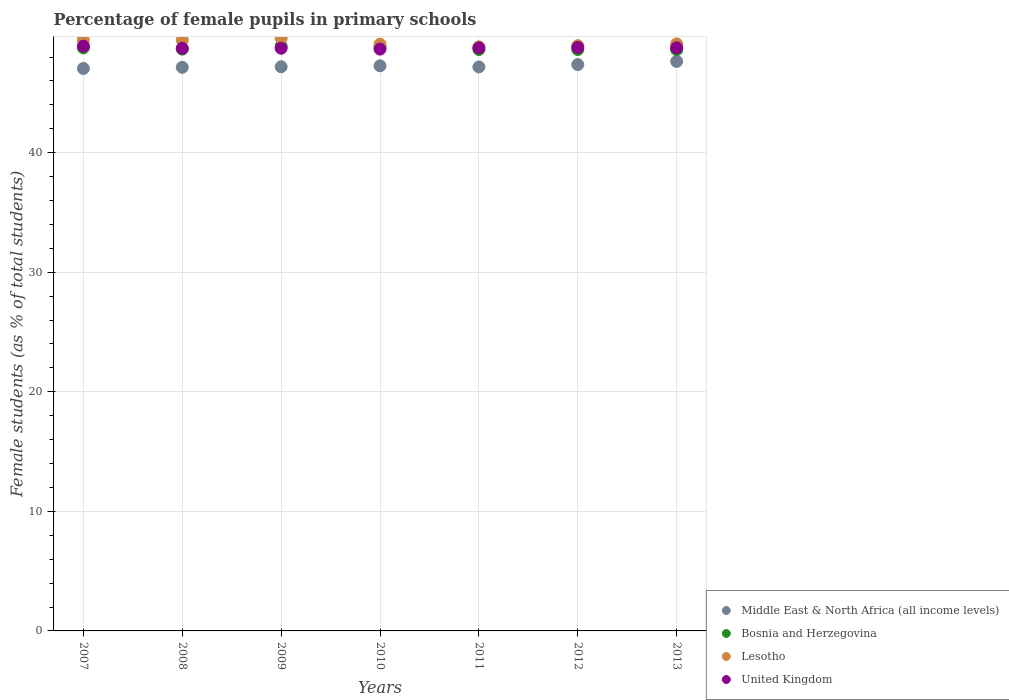What is the percentage of female pupils in primary schools in Lesotho in 2013?
Keep it short and to the point. 49.1. Across all years, what is the maximum percentage of female pupils in primary schools in Middle East & North Africa (all income levels)?
Give a very brief answer. 47.64. Across all years, what is the minimum percentage of female pupils in primary schools in United Kingdom?
Offer a terse response. 48.67. In which year was the percentage of female pupils in primary schools in Bosnia and Herzegovina maximum?
Provide a succinct answer. 2009. What is the total percentage of female pupils in primary schools in Lesotho in the graph?
Ensure brevity in your answer.  344.43. What is the difference between the percentage of female pupils in primary schools in Middle East & North Africa (all income levels) in 2011 and that in 2012?
Provide a short and direct response. -0.2. What is the difference between the percentage of female pupils in primary schools in United Kingdom in 2009 and the percentage of female pupils in primary schools in Bosnia and Herzegovina in 2007?
Keep it short and to the point. -0.04. What is the average percentage of female pupils in primary schools in Lesotho per year?
Your answer should be very brief. 49.2. In the year 2011, what is the difference between the percentage of female pupils in primary schools in United Kingdom and percentage of female pupils in primary schools in Middle East & North Africa (all income levels)?
Keep it short and to the point. 1.59. What is the ratio of the percentage of female pupils in primary schools in Bosnia and Herzegovina in 2010 to that in 2011?
Your answer should be very brief. 1. What is the difference between the highest and the second highest percentage of female pupils in primary schools in Middle East & North Africa (all income levels)?
Your response must be concise. 0.27. What is the difference between the highest and the lowest percentage of female pupils in primary schools in Lesotho?
Keep it short and to the point. 0.73. In how many years, is the percentage of female pupils in primary schools in Lesotho greater than the average percentage of female pupils in primary schools in Lesotho taken over all years?
Keep it short and to the point. 3. Is it the case that in every year, the sum of the percentage of female pupils in primary schools in Bosnia and Herzegovina and percentage of female pupils in primary schools in Middle East & North Africa (all income levels)  is greater than the sum of percentage of female pupils in primary schools in Lesotho and percentage of female pupils in primary schools in United Kingdom?
Provide a short and direct response. Yes. Is the percentage of female pupils in primary schools in Lesotho strictly less than the percentage of female pupils in primary schools in Bosnia and Herzegovina over the years?
Provide a short and direct response. No. Does the graph contain any zero values?
Offer a very short reply. No. What is the title of the graph?
Your answer should be compact. Percentage of female pupils in primary schools. What is the label or title of the Y-axis?
Offer a terse response. Female students (as % of total students). What is the Female students (as % of total students) of Middle East & North Africa (all income levels) in 2007?
Make the answer very short. 47.04. What is the Female students (as % of total students) of Bosnia and Herzegovina in 2007?
Keep it short and to the point. 48.77. What is the Female students (as % of total students) in Lesotho in 2007?
Your response must be concise. 49.44. What is the Female students (as % of total students) of United Kingdom in 2007?
Offer a terse response. 48.91. What is the Female students (as % of total students) of Middle East & North Africa (all income levels) in 2008?
Your response must be concise. 47.14. What is the Female students (as % of total students) in Bosnia and Herzegovina in 2008?
Your answer should be very brief. 48.67. What is the Female students (as % of total students) in Lesotho in 2008?
Your answer should be compact. 49.42. What is the Female students (as % of total students) of United Kingdom in 2008?
Make the answer very short. 48.73. What is the Female students (as % of total students) in Middle East & North Africa (all income levels) in 2009?
Make the answer very short. 47.19. What is the Female students (as % of total students) of Bosnia and Herzegovina in 2009?
Your answer should be compact. 48.91. What is the Female students (as % of total students) in Lesotho in 2009?
Offer a very short reply. 49.59. What is the Female students (as % of total students) of United Kingdom in 2009?
Offer a terse response. 48.74. What is the Female students (as % of total students) in Middle East & North Africa (all income levels) in 2010?
Offer a terse response. 47.27. What is the Female students (as % of total students) of Bosnia and Herzegovina in 2010?
Offer a very short reply. 48.86. What is the Female students (as % of total students) in Lesotho in 2010?
Your answer should be compact. 49.08. What is the Female students (as % of total students) in United Kingdom in 2010?
Give a very brief answer. 48.67. What is the Female students (as % of total students) of Middle East & North Africa (all income levels) in 2011?
Offer a very short reply. 47.17. What is the Female students (as % of total students) in Bosnia and Herzegovina in 2011?
Give a very brief answer. 48.63. What is the Female students (as % of total students) of Lesotho in 2011?
Your answer should be very brief. 48.86. What is the Female students (as % of total students) of United Kingdom in 2011?
Ensure brevity in your answer.  48.77. What is the Female students (as % of total students) in Middle East & North Africa (all income levels) in 2012?
Your response must be concise. 47.37. What is the Female students (as % of total students) of Bosnia and Herzegovina in 2012?
Give a very brief answer. 48.63. What is the Female students (as % of total students) in Lesotho in 2012?
Offer a terse response. 48.95. What is the Female students (as % of total students) of United Kingdom in 2012?
Provide a short and direct response. 48.81. What is the Female students (as % of total students) in Middle East & North Africa (all income levels) in 2013?
Offer a very short reply. 47.64. What is the Female students (as % of total students) in Bosnia and Herzegovina in 2013?
Keep it short and to the point. 48.61. What is the Female students (as % of total students) of Lesotho in 2013?
Offer a terse response. 49.1. What is the Female students (as % of total students) of United Kingdom in 2013?
Offer a very short reply. 48.77. Across all years, what is the maximum Female students (as % of total students) in Middle East & North Africa (all income levels)?
Ensure brevity in your answer.  47.64. Across all years, what is the maximum Female students (as % of total students) in Bosnia and Herzegovina?
Keep it short and to the point. 48.91. Across all years, what is the maximum Female students (as % of total students) of Lesotho?
Provide a succinct answer. 49.59. Across all years, what is the maximum Female students (as % of total students) of United Kingdom?
Your response must be concise. 48.91. Across all years, what is the minimum Female students (as % of total students) in Middle East & North Africa (all income levels)?
Offer a terse response. 47.04. Across all years, what is the minimum Female students (as % of total students) of Bosnia and Herzegovina?
Keep it short and to the point. 48.61. Across all years, what is the minimum Female students (as % of total students) in Lesotho?
Offer a terse response. 48.86. Across all years, what is the minimum Female students (as % of total students) of United Kingdom?
Offer a terse response. 48.67. What is the total Female students (as % of total students) in Middle East & North Africa (all income levels) in the graph?
Offer a very short reply. 330.83. What is the total Female students (as % of total students) in Bosnia and Herzegovina in the graph?
Your answer should be very brief. 341.09. What is the total Female students (as % of total students) of Lesotho in the graph?
Make the answer very short. 344.43. What is the total Female students (as % of total students) of United Kingdom in the graph?
Offer a terse response. 341.4. What is the difference between the Female students (as % of total students) in Middle East & North Africa (all income levels) in 2007 and that in 2008?
Keep it short and to the point. -0.1. What is the difference between the Female students (as % of total students) of Bosnia and Herzegovina in 2007 and that in 2008?
Provide a short and direct response. 0.1. What is the difference between the Female students (as % of total students) in Lesotho in 2007 and that in 2008?
Keep it short and to the point. 0.02. What is the difference between the Female students (as % of total students) in United Kingdom in 2007 and that in 2008?
Your answer should be compact. 0.18. What is the difference between the Female students (as % of total students) in Middle East & North Africa (all income levels) in 2007 and that in 2009?
Your answer should be very brief. -0.15. What is the difference between the Female students (as % of total students) of Bosnia and Herzegovina in 2007 and that in 2009?
Make the answer very short. -0.14. What is the difference between the Female students (as % of total students) of Lesotho in 2007 and that in 2009?
Offer a very short reply. -0.15. What is the difference between the Female students (as % of total students) in United Kingdom in 2007 and that in 2009?
Your response must be concise. 0.18. What is the difference between the Female students (as % of total students) of Middle East & North Africa (all income levels) in 2007 and that in 2010?
Provide a short and direct response. -0.23. What is the difference between the Female students (as % of total students) in Bosnia and Herzegovina in 2007 and that in 2010?
Ensure brevity in your answer.  -0.09. What is the difference between the Female students (as % of total students) in Lesotho in 2007 and that in 2010?
Provide a succinct answer. 0.36. What is the difference between the Female students (as % of total students) of United Kingdom in 2007 and that in 2010?
Your answer should be very brief. 0.25. What is the difference between the Female students (as % of total students) of Middle East & North Africa (all income levels) in 2007 and that in 2011?
Make the answer very short. -0.13. What is the difference between the Female students (as % of total students) of Bosnia and Herzegovina in 2007 and that in 2011?
Your answer should be compact. 0.14. What is the difference between the Female students (as % of total students) of Lesotho in 2007 and that in 2011?
Offer a terse response. 0.58. What is the difference between the Female students (as % of total students) of United Kingdom in 2007 and that in 2011?
Offer a terse response. 0.14. What is the difference between the Female students (as % of total students) of Middle East & North Africa (all income levels) in 2007 and that in 2012?
Your answer should be compact. -0.33. What is the difference between the Female students (as % of total students) in Bosnia and Herzegovina in 2007 and that in 2012?
Ensure brevity in your answer.  0.14. What is the difference between the Female students (as % of total students) of Lesotho in 2007 and that in 2012?
Make the answer very short. 0.49. What is the difference between the Female students (as % of total students) of United Kingdom in 2007 and that in 2012?
Provide a succinct answer. 0.1. What is the difference between the Female students (as % of total students) in Middle East & North Africa (all income levels) in 2007 and that in 2013?
Offer a very short reply. -0.59. What is the difference between the Female students (as % of total students) in Bosnia and Herzegovina in 2007 and that in 2013?
Make the answer very short. 0.16. What is the difference between the Female students (as % of total students) of Lesotho in 2007 and that in 2013?
Keep it short and to the point. 0.34. What is the difference between the Female students (as % of total students) of United Kingdom in 2007 and that in 2013?
Make the answer very short. 0.14. What is the difference between the Female students (as % of total students) in Middle East & North Africa (all income levels) in 2008 and that in 2009?
Make the answer very short. -0.05. What is the difference between the Female students (as % of total students) of Bosnia and Herzegovina in 2008 and that in 2009?
Ensure brevity in your answer.  -0.24. What is the difference between the Female students (as % of total students) in Lesotho in 2008 and that in 2009?
Your response must be concise. -0.17. What is the difference between the Female students (as % of total students) of United Kingdom in 2008 and that in 2009?
Ensure brevity in your answer.  -0.01. What is the difference between the Female students (as % of total students) of Middle East & North Africa (all income levels) in 2008 and that in 2010?
Provide a succinct answer. -0.13. What is the difference between the Female students (as % of total students) of Bosnia and Herzegovina in 2008 and that in 2010?
Ensure brevity in your answer.  -0.19. What is the difference between the Female students (as % of total students) in Lesotho in 2008 and that in 2010?
Keep it short and to the point. 0.34. What is the difference between the Female students (as % of total students) in United Kingdom in 2008 and that in 2010?
Offer a very short reply. 0.06. What is the difference between the Female students (as % of total students) in Middle East & North Africa (all income levels) in 2008 and that in 2011?
Provide a short and direct response. -0.03. What is the difference between the Female students (as % of total students) in Bosnia and Herzegovina in 2008 and that in 2011?
Give a very brief answer. 0.03. What is the difference between the Female students (as % of total students) of Lesotho in 2008 and that in 2011?
Ensure brevity in your answer.  0.56. What is the difference between the Female students (as % of total students) in United Kingdom in 2008 and that in 2011?
Your answer should be compact. -0.04. What is the difference between the Female students (as % of total students) of Middle East & North Africa (all income levels) in 2008 and that in 2012?
Your answer should be compact. -0.23. What is the difference between the Female students (as % of total students) in Bosnia and Herzegovina in 2008 and that in 2012?
Your response must be concise. 0.04. What is the difference between the Female students (as % of total students) in Lesotho in 2008 and that in 2012?
Offer a very short reply. 0.47. What is the difference between the Female students (as % of total students) in United Kingdom in 2008 and that in 2012?
Provide a short and direct response. -0.08. What is the difference between the Female students (as % of total students) of Middle East & North Africa (all income levels) in 2008 and that in 2013?
Make the answer very short. -0.5. What is the difference between the Female students (as % of total students) of Bosnia and Herzegovina in 2008 and that in 2013?
Provide a short and direct response. 0.05. What is the difference between the Female students (as % of total students) of Lesotho in 2008 and that in 2013?
Keep it short and to the point. 0.31. What is the difference between the Female students (as % of total students) in United Kingdom in 2008 and that in 2013?
Provide a succinct answer. -0.04. What is the difference between the Female students (as % of total students) in Middle East & North Africa (all income levels) in 2009 and that in 2010?
Provide a succinct answer. -0.08. What is the difference between the Female students (as % of total students) in Bosnia and Herzegovina in 2009 and that in 2010?
Your answer should be compact. 0.05. What is the difference between the Female students (as % of total students) of Lesotho in 2009 and that in 2010?
Your answer should be compact. 0.51. What is the difference between the Female students (as % of total students) in United Kingdom in 2009 and that in 2010?
Offer a terse response. 0.07. What is the difference between the Female students (as % of total students) of Middle East & North Africa (all income levels) in 2009 and that in 2011?
Offer a very short reply. 0.02. What is the difference between the Female students (as % of total students) in Bosnia and Herzegovina in 2009 and that in 2011?
Provide a succinct answer. 0.28. What is the difference between the Female students (as % of total students) in Lesotho in 2009 and that in 2011?
Your answer should be compact. 0.73. What is the difference between the Female students (as % of total students) of United Kingdom in 2009 and that in 2011?
Keep it short and to the point. -0.03. What is the difference between the Female students (as % of total students) in Middle East & North Africa (all income levels) in 2009 and that in 2012?
Give a very brief answer. -0.18. What is the difference between the Female students (as % of total students) in Bosnia and Herzegovina in 2009 and that in 2012?
Give a very brief answer. 0.28. What is the difference between the Female students (as % of total students) in Lesotho in 2009 and that in 2012?
Your answer should be compact. 0.64. What is the difference between the Female students (as % of total students) of United Kingdom in 2009 and that in 2012?
Your answer should be compact. -0.07. What is the difference between the Female students (as % of total students) in Middle East & North Africa (all income levels) in 2009 and that in 2013?
Provide a succinct answer. -0.45. What is the difference between the Female students (as % of total students) in Bosnia and Herzegovina in 2009 and that in 2013?
Give a very brief answer. 0.3. What is the difference between the Female students (as % of total students) in Lesotho in 2009 and that in 2013?
Give a very brief answer. 0.48. What is the difference between the Female students (as % of total students) in United Kingdom in 2009 and that in 2013?
Provide a succinct answer. -0.04. What is the difference between the Female students (as % of total students) of Middle East & North Africa (all income levels) in 2010 and that in 2011?
Your response must be concise. 0.1. What is the difference between the Female students (as % of total students) in Bosnia and Herzegovina in 2010 and that in 2011?
Your answer should be compact. 0.23. What is the difference between the Female students (as % of total students) in Lesotho in 2010 and that in 2011?
Make the answer very short. 0.23. What is the difference between the Female students (as % of total students) of United Kingdom in 2010 and that in 2011?
Provide a succinct answer. -0.1. What is the difference between the Female students (as % of total students) of Middle East & North Africa (all income levels) in 2010 and that in 2012?
Offer a terse response. -0.1. What is the difference between the Female students (as % of total students) of Bosnia and Herzegovina in 2010 and that in 2012?
Offer a very short reply. 0.23. What is the difference between the Female students (as % of total students) in Lesotho in 2010 and that in 2012?
Keep it short and to the point. 0.13. What is the difference between the Female students (as % of total students) in United Kingdom in 2010 and that in 2012?
Provide a short and direct response. -0.14. What is the difference between the Female students (as % of total students) of Middle East & North Africa (all income levels) in 2010 and that in 2013?
Your response must be concise. -0.37. What is the difference between the Female students (as % of total students) in Bosnia and Herzegovina in 2010 and that in 2013?
Your answer should be compact. 0.24. What is the difference between the Female students (as % of total students) of Lesotho in 2010 and that in 2013?
Offer a very short reply. -0.02. What is the difference between the Female students (as % of total students) of United Kingdom in 2010 and that in 2013?
Provide a succinct answer. -0.11. What is the difference between the Female students (as % of total students) of Middle East & North Africa (all income levels) in 2011 and that in 2012?
Your answer should be very brief. -0.2. What is the difference between the Female students (as % of total students) in Bosnia and Herzegovina in 2011 and that in 2012?
Your answer should be very brief. 0. What is the difference between the Female students (as % of total students) of Lesotho in 2011 and that in 2012?
Provide a succinct answer. -0.1. What is the difference between the Female students (as % of total students) of United Kingdom in 2011 and that in 2012?
Ensure brevity in your answer.  -0.04. What is the difference between the Female students (as % of total students) in Middle East & North Africa (all income levels) in 2011 and that in 2013?
Give a very brief answer. -0.46. What is the difference between the Female students (as % of total students) of Bosnia and Herzegovina in 2011 and that in 2013?
Offer a terse response. 0.02. What is the difference between the Female students (as % of total students) of Lesotho in 2011 and that in 2013?
Offer a terse response. -0.25. What is the difference between the Female students (as % of total students) in United Kingdom in 2011 and that in 2013?
Provide a short and direct response. -0.01. What is the difference between the Female students (as % of total students) of Middle East & North Africa (all income levels) in 2012 and that in 2013?
Offer a terse response. -0.27. What is the difference between the Female students (as % of total students) in Bosnia and Herzegovina in 2012 and that in 2013?
Provide a short and direct response. 0.02. What is the difference between the Female students (as % of total students) of Lesotho in 2012 and that in 2013?
Your answer should be very brief. -0.15. What is the difference between the Female students (as % of total students) in United Kingdom in 2012 and that in 2013?
Provide a succinct answer. 0.04. What is the difference between the Female students (as % of total students) in Middle East & North Africa (all income levels) in 2007 and the Female students (as % of total students) in Bosnia and Herzegovina in 2008?
Offer a terse response. -1.62. What is the difference between the Female students (as % of total students) of Middle East & North Africa (all income levels) in 2007 and the Female students (as % of total students) of Lesotho in 2008?
Your answer should be compact. -2.37. What is the difference between the Female students (as % of total students) in Middle East & North Africa (all income levels) in 2007 and the Female students (as % of total students) in United Kingdom in 2008?
Ensure brevity in your answer.  -1.69. What is the difference between the Female students (as % of total students) in Bosnia and Herzegovina in 2007 and the Female students (as % of total students) in Lesotho in 2008?
Offer a very short reply. -0.64. What is the difference between the Female students (as % of total students) in Bosnia and Herzegovina in 2007 and the Female students (as % of total students) in United Kingdom in 2008?
Provide a succinct answer. 0.04. What is the difference between the Female students (as % of total students) in Lesotho in 2007 and the Female students (as % of total students) in United Kingdom in 2008?
Keep it short and to the point. 0.71. What is the difference between the Female students (as % of total students) of Middle East & North Africa (all income levels) in 2007 and the Female students (as % of total students) of Bosnia and Herzegovina in 2009?
Offer a very short reply. -1.87. What is the difference between the Female students (as % of total students) of Middle East & North Africa (all income levels) in 2007 and the Female students (as % of total students) of Lesotho in 2009?
Keep it short and to the point. -2.54. What is the difference between the Female students (as % of total students) in Middle East & North Africa (all income levels) in 2007 and the Female students (as % of total students) in United Kingdom in 2009?
Your answer should be compact. -1.69. What is the difference between the Female students (as % of total students) of Bosnia and Herzegovina in 2007 and the Female students (as % of total students) of Lesotho in 2009?
Provide a succinct answer. -0.81. What is the difference between the Female students (as % of total students) in Bosnia and Herzegovina in 2007 and the Female students (as % of total students) in United Kingdom in 2009?
Give a very brief answer. 0.04. What is the difference between the Female students (as % of total students) of Lesotho in 2007 and the Female students (as % of total students) of United Kingdom in 2009?
Your answer should be very brief. 0.7. What is the difference between the Female students (as % of total students) in Middle East & North Africa (all income levels) in 2007 and the Female students (as % of total students) in Bosnia and Herzegovina in 2010?
Keep it short and to the point. -1.82. What is the difference between the Female students (as % of total students) of Middle East & North Africa (all income levels) in 2007 and the Female students (as % of total students) of Lesotho in 2010?
Make the answer very short. -2.04. What is the difference between the Female students (as % of total students) in Middle East & North Africa (all income levels) in 2007 and the Female students (as % of total students) in United Kingdom in 2010?
Offer a terse response. -1.62. What is the difference between the Female students (as % of total students) in Bosnia and Herzegovina in 2007 and the Female students (as % of total students) in Lesotho in 2010?
Your answer should be compact. -0.31. What is the difference between the Female students (as % of total students) in Bosnia and Herzegovina in 2007 and the Female students (as % of total students) in United Kingdom in 2010?
Give a very brief answer. 0.11. What is the difference between the Female students (as % of total students) of Lesotho in 2007 and the Female students (as % of total students) of United Kingdom in 2010?
Your answer should be very brief. 0.77. What is the difference between the Female students (as % of total students) in Middle East & North Africa (all income levels) in 2007 and the Female students (as % of total students) in Bosnia and Herzegovina in 2011?
Offer a very short reply. -1.59. What is the difference between the Female students (as % of total students) in Middle East & North Africa (all income levels) in 2007 and the Female students (as % of total students) in Lesotho in 2011?
Offer a terse response. -1.81. What is the difference between the Female students (as % of total students) of Middle East & North Africa (all income levels) in 2007 and the Female students (as % of total students) of United Kingdom in 2011?
Your answer should be very brief. -1.72. What is the difference between the Female students (as % of total students) in Bosnia and Herzegovina in 2007 and the Female students (as % of total students) in Lesotho in 2011?
Ensure brevity in your answer.  -0.08. What is the difference between the Female students (as % of total students) in Bosnia and Herzegovina in 2007 and the Female students (as % of total students) in United Kingdom in 2011?
Offer a very short reply. 0. What is the difference between the Female students (as % of total students) of Lesotho in 2007 and the Female students (as % of total students) of United Kingdom in 2011?
Keep it short and to the point. 0.67. What is the difference between the Female students (as % of total students) of Middle East & North Africa (all income levels) in 2007 and the Female students (as % of total students) of Bosnia and Herzegovina in 2012?
Make the answer very short. -1.59. What is the difference between the Female students (as % of total students) of Middle East & North Africa (all income levels) in 2007 and the Female students (as % of total students) of Lesotho in 2012?
Your answer should be compact. -1.91. What is the difference between the Female students (as % of total students) in Middle East & North Africa (all income levels) in 2007 and the Female students (as % of total students) in United Kingdom in 2012?
Keep it short and to the point. -1.76. What is the difference between the Female students (as % of total students) in Bosnia and Herzegovina in 2007 and the Female students (as % of total students) in Lesotho in 2012?
Keep it short and to the point. -0.18. What is the difference between the Female students (as % of total students) of Bosnia and Herzegovina in 2007 and the Female students (as % of total students) of United Kingdom in 2012?
Offer a terse response. -0.04. What is the difference between the Female students (as % of total students) in Lesotho in 2007 and the Female students (as % of total students) in United Kingdom in 2012?
Make the answer very short. 0.63. What is the difference between the Female students (as % of total students) in Middle East & North Africa (all income levels) in 2007 and the Female students (as % of total students) in Bosnia and Herzegovina in 2013?
Make the answer very short. -1.57. What is the difference between the Female students (as % of total students) in Middle East & North Africa (all income levels) in 2007 and the Female students (as % of total students) in Lesotho in 2013?
Give a very brief answer. -2.06. What is the difference between the Female students (as % of total students) in Middle East & North Africa (all income levels) in 2007 and the Female students (as % of total students) in United Kingdom in 2013?
Offer a very short reply. -1.73. What is the difference between the Female students (as % of total students) of Bosnia and Herzegovina in 2007 and the Female students (as % of total students) of Lesotho in 2013?
Keep it short and to the point. -0.33. What is the difference between the Female students (as % of total students) of Bosnia and Herzegovina in 2007 and the Female students (as % of total students) of United Kingdom in 2013?
Your response must be concise. -0. What is the difference between the Female students (as % of total students) of Lesotho in 2007 and the Female students (as % of total students) of United Kingdom in 2013?
Make the answer very short. 0.67. What is the difference between the Female students (as % of total students) of Middle East & North Africa (all income levels) in 2008 and the Female students (as % of total students) of Bosnia and Herzegovina in 2009?
Your answer should be compact. -1.77. What is the difference between the Female students (as % of total students) in Middle East & North Africa (all income levels) in 2008 and the Female students (as % of total students) in Lesotho in 2009?
Your response must be concise. -2.45. What is the difference between the Female students (as % of total students) in Middle East & North Africa (all income levels) in 2008 and the Female students (as % of total students) in United Kingdom in 2009?
Your response must be concise. -1.6. What is the difference between the Female students (as % of total students) of Bosnia and Herzegovina in 2008 and the Female students (as % of total students) of Lesotho in 2009?
Give a very brief answer. -0.92. What is the difference between the Female students (as % of total students) of Bosnia and Herzegovina in 2008 and the Female students (as % of total students) of United Kingdom in 2009?
Provide a succinct answer. -0.07. What is the difference between the Female students (as % of total students) in Lesotho in 2008 and the Female students (as % of total students) in United Kingdom in 2009?
Ensure brevity in your answer.  0.68. What is the difference between the Female students (as % of total students) of Middle East & North Africa (all income levels) in 2008 and the Female students (as % of total students) of Bosnia and Herzegovina in 2010?
Provide a succinct answer. -1.72. What is the difference between the Female students (as % of total students) of Middle East & North Africa (all income levels) in 2008 and the Female students (as % of total students) of Lesotho in 2010?
Give a very brief answer. -1.94. What is the difference between the Female students (as % of total students) in Middle East & North Africa (all income levels) in 2008 and the Female students (as % of total students) in United Kingdom in 2010?
Make the answer very short. -1.53. What is the difference between the Female students (as % of total students) in Bosnia and Herzegovina in 2008 and the Female students (as % of total students) in Lesotho in 2010?
Make the answer very short. -0.41. What is the difference between the Female students (as % of total students) in Bosnia and Herzegovina in 2008 and the Female students (as % of total students) in United Kingdom in 2010?
Make the answer very short. 0. What is the difference between the Female students (as % of total students) of Lesotho in 2008 and the Female students (as % of total students) of United Kingdom in 2010?
Your response must be concise. 0.75. What is the difference between the Female students (as % of total students) in Middle East & North Africa (all income levels) in 2008 and the Female students (as % of total students) in Bosnia and Herzegovina in 2011?
Offer a terse response. -1.49. What is the difference between the Female students (as % of total students) in Middle East & North Africa (all income levels) in 2008 and the Female students (as % of total students) in Lesotho in 2011?
Your answer should be compact. -1.71. What is the difference between the Female students (as % of total students) of Middle East & North Africa (all income levels) in 2008 and the Female students (as % of total students) of United Kingdom in 2011?
Ensure brevity in your answer.  -1.63. What is the difference between the Female students (as % of total students) in Bosnia and Herzegovina in 2008 and the Female students (as % of total students) in Lesotho in 2011?
Offer a terse response. -0.19. What is the difference between the Female students (as % of total students) of Bosnia and Herzegovina in 2008 and the Female students (as % of total students) of United Kingdom in 2011?
Your answer should be compact. -0.1. What is the difference between the Female students (as % of total students) in Lesotho in 2008 and the Female students (as % of total students) in United Kingdom in 2011?
Offer a terse response. 0.65. What is the difference between the Female students (as % of total students) in Middle East & North Africa (all income levels) in 2008 and the Female students (as % of total students) in Bosnia and Herzegovina in 2012?
Provide a short and direct response. -1.49. What is the difference between the Female students (as % of total students) of Middle East & North Africa (all income levels) in 2008 and the Female students (as % of total students) of Lesotho in 2012?
Ensure brevity in your answer.  -1.81. What is the difference between the Female students (as % of total students) of Middle East & North Africa (all income levels) in 2008 and the Female students (as % of total students) of United Kingdom in 2012?
Give a very brief answer. -1.67. What is the difference between the Female students (as % of total students) in Bosnia and Herzegovina in 2008 and the Female students (as % of total students) in Lesotho in 2012?
Your answer should be very brief. -0.28. What is the difference between the Female students (as % of total students) of Bosnia and Herzegovina in 2008 and the Female students (as % of total students) of United Kingdom in 2012?
Your answer should be very brief. -0.14. What is the difference between the Female students (as % of total students) in Lesotho in 2008 and the Female students (as % of total students) in United Kingdom in 2012?
Your answer should be compact. 0.61. What is the difference between the Female students (as % of total students) of Middle East & North Africa (all income levels) in 2008 and the Female students (as % of total students) of Bosnia and Herzegovina in 2013?
Your answer should be compact. -1.47. What is the difference between the Female students (as % of total students) of Middle East & North Africa (all income levels) in 2008 and the Female students (as % of total students) of Lesotho in 2013?
Offer a terse response. -1.96. What is the difference between the Female students (as % of total students) in Middle East & North Africa (all income levels) in 2008 and the Female students (as % of total students) in United Kingdom in 2013?
Offer a terse response. -1.63. What is the difference between the Female students (as % of total students) in Bosnia and Herzegovina in 2008 and the Female students (as % of total students) in Lesotho in 2013?
Ensure brevity in your answer.  -0.43. What is the difference between the Female students (as % of total students) in Bosnia and Herzegovina in 2008 and the Female students (as % of total students) in United Kingdom in 2013?
Your answer should be compact. -0.11. What is the difference between the Female students (as % of total students) in Lesotho in 2008 and the Female students (as % of total students) in United Kingdom in 2013?
Offer a terse response. 0.64. What is the difference between the Female students (as % of total students) of Middle East & North Africa (all income levels) in 2009 and the Female students (as % of total students) of Bosnia and Herzegovina in 2010?
Ensure brevity in your answer.  -1.67. What is the difference between the Female students (as % of total students) of Middle East & North Africa (all income levels) in 2009 and the Female students (as % of total students) of Lesotho in 2010?
Your answer should be compact. -1.89. What is the difference between the Female students (as % of total students) in Middle East & North Africa (all income levels) in 2009 and the Female students (as % of total students) in United Kingdom in 2010?
Offer a terse response. -1.48. What is the difference between the Female students (as % of total students) of Bosnia and Herzegovina in 2009 and the Female students (as % of total students) of Lesotho in 2010?
Offer a terse response. -0.17. What is the difference between the Female students (as % of total students) of Bosnia and Herzegovina in 2009 and the Female students (as % of total students) of United Kingdom in 2010?
Provide a short and direct response. 0.24. What is the difference between the Female students (as % of total students) in Lesotho in 2009 and the Female students (as % of total students) in United Kingdom in 2010?
Offer a terse response. 0.92. What is the difference between the Female students (as % of total students) of Middle East & North Africa (all income levels) in 2009 and the Female students (as % of total students) of Bosnia and Herzegovina in 2011?
Your answer should be very brief. -1.44. What is the difference between the Female students (as % of total students) of Middle East & North Africa (all income levels) in 2009 and the Female students (as % of total students) of Lesotho in 2011?
Provide a short and direct response. -1.66. What is the difference between the Female students (as % of total students) of Middle East & North Africa (all income levels) in 2009 and the Female students (as % of total students) of United Kingdom in 2011?
Keep it short and to the point. -1.58. What is the difference between the Female students (as % of total students) in Bosnia and Herzegovina in 2009 and the Female students (as % of total students) in Lesotho in 2011?
Keep it short and to the point. 0.06. What is the difference between the Female students (as % of total students) of Bosnia and Herzegovina in 2009 and the Female students (as % of total students) of United Kingdom in 2011?
Your answer should be compact. 0.14. What is the difference between the Female students (as % of total students) of Lesotho in 2009 and the Female students (as % of total students) of United Kingdom in 2011?
Offer a very short reply. 0.82. What is the difference between the Female students (as % of total students) in Middle East & North Africa (all income levels) in 2009 and the Female students (as % of total students) in Bosnia and Herzegovina in 2012?
Your answer should be compact. -1.44. What is the difference between the Female students (as % of total students) of Middle East & North Africa (all income levels) in 2009 and the Female students (as % of total students) of Lesotho in 2012?
Provide a succinct answer. -1.76. What is the difference between the Female students (as % of total students) in Middle East & North Africa (all income levels) in 2009 and the Female students (as % of total students) in United Kingdom in 2012?
Keep it short and to the point. -1.62. What is the difference between the Female students (as % of total students) of Bosnia and Herzegovina in 2009 and the Female students (as % of total students) of Lesotho in 2012?
Offer a terse response. -0.04. What is the difference between the Female students (as % of total students) of Bosnia and Herzegovina in 2009 and the Female students (as % of total students) of United Kingdom in 2012?
Offer a very short reply. 0.1. What is the difference between the Female students (as % of total students) of Lesotho in 2009 and the Female students (as % of total students) of United Kingdom in 2012?
Keep it short and to the point. 0.78. What is the difference between the Female students (as % of total students) in Middle East & North Africa (all income levels) in 2009 and the Female students (as % of total students) in Bosnia and Herzegovina in 2013?
Give a very brief answer. -1.42. What is the difference between the Female students (as % of total students) in Middle East & North Africa (all income levels) in 2009 and the Female students (as % of total students) in Lesotho in 2013?
Give a very brief answer. -1.91. What is the difference between the Female students (as % of total students) of Middle East & North Africa (all income levels) in 2009 and the Female students (as % of total students) of United Kingdom in 2013?
Keep it short and to the point. -1.58. What is the difference between the Female students (as % of total students) of Bosnia and Herzegovina in 2009 and the Female students (as % of total students) of Lesotho in 2013?
Provide a succinct answer. -0.19. What is the difference between the Female students (as % of total students) of Bosnia and Herzegovina in 2009 and the Female students (as % of total students) of United Kingdom in 2013?
Your answer should be compact. 0.14. What is the difference between the Female students (as % of total students) of Lesotho in 2009 and the Female students (as % of total students) of United Kingdom in 2013?
Your answer should be very brief. 0.81. What is the difference between the Female students (as % of total students) of Middle East & North Africa (all income levels) in 2010 and the Female students (as % of total students) of Bosnia and Herzegovina in 2011?
Your answer should be compact. -1.36. What is the difference between the Female students (as % of total students) in Middle East & North Africa (all income levels) in 2010 and the Female students (as % of total students) in Lesotho in 2011?
Offer a very short reply. -1.58. What is the difference between the Female students (as % of total students) in Middle East & North Africa (all income levels) in 2010 and the Female students (as % of total students) in United Kingdom in 2011?
Give a very brief answer. -1.5. What is the difference between the Female students (as % of total students) of Bosnia and Herzegovina in 2010 and the Female students (as % of total students) of Lesotho in 2011?
Give a very brief answer. 0. What is the difference between the Female students (as % of total students) of Bosnia and Herzegovina in 2010 and the Female students (as % of total students) of United Kingdom in 2011?
Your response must be concise. 0.09. What is the difference between the Female students (as % of total students) in Lesotho in 2010 and the Female students (as % of total students) in United Kingdom in 2011?
Provide a succinct answer. 0.31. What is the difference between the Female students (as % of total students) of Middle East & North Africa (all income levels) in 2010 and the Female students (as % of total students) of Bosnia and Herzegovina in 2012?
Make the answer very short. -1.36. What is the difference between the Female students (as % of total students) of Middle East & North Africa (all income levels) in 2010 and the Female students (as % of total students) of Lesotho in 2012?
Make the answer very short. -1.68. What is the difference between the Female students (as % of total students) in Middle East & North Africa (all income levels) in 2010 and the Female students (as % of total students) in United Kingdom in 2012?
Offer a terse response. -1.54. What is the difference between the Female students (as % of total students) of Bosnia and Herzegovina in 2010 and the Female students (as % of total students) of Lesotho in 2012?
Make the answer very short. -0.09. What is the difference between the Female students (as % of total students) in Bosnia and Herzegovina in 2010 and the Female students (as % of total students) in United Kingdom in 2012?
Your answer should be very brief. 0.05. What is the difference between the Female students (as % of total students) in Lesotho in 2010 and the Female students (as % of total students) in United Kingdom in 2012?
Your answer should be very brief. 0.27. What is the difference between the Female students (as % of total students) in Middle East & North Africa (all income levels) in 2010 and the Female students (as % of total students) in Bosnia and Herzegovina in 2013?
Your answer should be compact. -1.34. What is the difference between the Female students (as % of total students) of Middle East & North Africa (all income levels) in 2010 and the Female students (as % of total students) of Lesotho in 2013?
Give a very brief answer. -1.83. What is the difference between the Female students (as % of total students) of Middle East & North Africa (all income levels) in 2010 and the Female students (as % of total students) of United Kingdom in 2013?
Keep it short and to the point. -1.5. What is the difference between the Female students (as % of total students) in Bosnia and Herzegovina in 2010 and the Female students (as % of total students) in Lesotho in 2013?
Provide a succinct answer. -0.24. What is the difference between the Female students (as % of total students) of Bosnia and Herzegovina in 2010 and the Female students (as % of total students) of United Kingdom in 2013?
Ensure brevity in your answer.  0.09. What is the difference between the Female students (as % of total students) of Lesotho in 2010 and the Female students (as % of total students) of United Kingdom in 2013?
Ensure brevity in your answer.  0.31. What is the difference between the Female students (as % of total students) in Middle East & North Africa (all income levels) in 2011 and the Female students (as % of total students) in Bosnia and Herzegovina in 2012?
Keep it short and to the point. -1.46. What is the difference between the Female students (as % of total students) of Middle East & North Africa (all income levels) in 2011 and the Female students (as % of total students) of Lesotho in 2012?
Make the answer very short. -1.78. What is the difference between the Female students (as % of total students) in Middle East & North Africa (all income levels) in 2011 and the Female students (as % of total students) in United Kingdom in 2012?
Make the answer very short. -1.63. What is the difference between the Female students (as % of total students) in Bosnia and Herzegovina in 2011 and the Female students (as % of total students) in Lesotho in 2012?
Keep it short and to the point. -0.32. What is the difference between the Female students (as % of total students) in Bosnia and Herzegovina in 2011 and the Female students (as % of total students) in United Kingdom in 2012?
Provide a short and direct response. -0.17. What is the difference between the Female students (as % of total students) in Lesotho in 2011 and the Female students (as % of total students) in United Kingdom in 2012?
Your answer should be very brief. 0.05. What is the difference between the Female students (as % of total students) in Middle East & North Africa (all income levels) in 2011 and the Female students (as % of total students) in Bosnia and Herzegovina in 2013?
Your answer should be very brief. -1.44. What is the difference between the Female students (as % of total students) in Middle East & North Africa (all income levels) in 2011 and the Female students (as % of total students) in Lesotho in 2013?
Your answer should be very brief. -1.93. What is the difference between the Female students (as % of total students) of Middle East & North Africa (all income levels) in 2011 and the Female students (as % of total students) of United Kingdom in 2013?
Offer a very short reply. -1.6. What is the difference between the Female students (as % of total students) of Bosnia and Herzegovina in 2011 and the Female students (as % of total students) of Lesotho in 2013?
Your response must be concise. -0.47. What is the difference between the Female students (as % of total students) in Bosnia and Herzegovina in 2011 and the Female students (as % of total students) in United Kingdom in 2013?
Your answer should be very brief. -0.14. What is the difference between the Female students (as % of total students) of Lesotho in 2011 and the Female students (as % of total students) of United Kingdom in 2013?
Give a very brief answer. 0.08. What is the difference between the Female students (as % of total students) of Middle East & North Africa (all income levels) in 2012 and the Female students (as % of total students) of Bosnia and Herzegovina in 2013?
Your answer should be very brief. -1.24. What is the difference between the Female students (as % of total students) in Middle East & North Africa (all income levels) in 2012 and the Female students (as % of total students) in Lesotho in 2013?
Provide a short and direct response. -1.73. What is the difference between the Female students (as % of total students) of Middle East & North Africa (all income levels) in 2012 and the Female students (as % of total students) of United Kingdom in 2013?
Give a very brief answer. -1.4. What is the difference between the Female students (as % of total students) in Bosnia and Herzegovina in 2012 and the Female students (as % of total students) in Lesotho in 2013?
Provide a succinct answer. -0.47. What is the difference between the Female students (as % of total students) in Bosnia and Herzegovina in 2012 and the Female students (as % of total students) in United Kingdom in 2013?
Offer a very short reply. -0.14. What is the difference between the Female students (as % of total students) in Lesotho in 2012 and the Female students (as % of total students) in United Kingdom in 2013?
Your answer should be compact. 0.18. What is the average Female students (as % of total students) in Middle East & North Africa (all income levels) per year?
Keep it short and to the point. 47.26. What is the average Female students (as % of total students) in Bosnia and Herzegovina per year?
Provide a short and direct response. 48.73. What is the average Female students (as % of total students) in Lesotho per year?
Offer a terse response. 49.2. What is the average Female students (as % of total students) in United Kingdom per year?
Offer a terse response. 48.77. In the year 2007, what is the difference between the Female students (as % of total students) of Middle East & North Africa (all income levels) and Female students (as % of total students) of Bosnia and Herzegovina?
Provide a short and direct response. -1.73. In the year 2007, what is the difference between the Female students (as % of total students) in Middle East & North Africa (all income levels) and Female students (as % of total students) in Lesotho?
Provide a short and direct response. -2.4. In the year 2007, what is the difference between the Female students (as % of total students) of Middle East & North Africa (all income levels) and Female students (as % of total students) of United Kingdom?
Provide a short and direct response. -1.87. In the year 2007, what is the difference between the Female students (as % of total students) of Bosnia and Herzegovina and Female students (as % of total students) of Lesotho?
Your answer should be compact. -0.67. In the year 2007, what is the difference between the Female students (as % of total students) of Bosnia and Herzegovina and Female students (as % of total students) of United Kingdom?
Offer a terse response. -0.14. In the year 2007, what is the difference between the Female students (as % of total students) of Lesotho and Female students (as % of total students) of United Kingdom?
Give a very brief answer. 0.53. In the year 2008, what is the difference between the Female students (as % of total students) in Middle East & North Africa (all income levels) and Female students (as % of total students) in Bosnia and Herzegovina?
Offer a very short reply. -1.53. In the year 2008, what is the difference between the Female students (as % of total students) of Middle East & North Africa (all income levels) and Female students (as % of total students) of Lesotho?
Offer a terse response. -2.28. In the year 2008, what is the difference between the Female students (as % of total students) in Middle East & North Africa (all income levels) and Female students (as % of total students) in United Kingdom?
Offer a terse response. -1.59. In the year 2008, what is the difference between the Female students (as % of total students) in Bosnia and Herzegovina and Female students (as % of total students) in Lesotho?
Ensure brevity in your answer.  -0.75. In the year 2008, what is the difference between the Female students (as % of total students) in Bosnia and Herzegovina and Female students (as % of total students) in United Kingdom?
Provide a succinct answer. -0.06. In the year 2008, what is the difference between the Female students (as % of total students) in Lesotho and Female students (as % of total students) in United Kingdom?
Keep it short and to the point. 0.68. In the year 2009, what is the difference between the Female students (as % of total students) in Middle East & North Africa (all income levels) and Female students (as % of total students) in Bosnia and Herzegovina?
Offer a very short reply. -1.72. In the year 2009, what is the difference between the Female students (as % of total students) of Middle East & North Africa (all income levels) and Female students (as % of total students) of Lesotho?
Offer a terse response. -2.4. In the year 2009, what is the difference between the Female students (as % of total students) of Middle East & North Africa (all income levels) and Female students (as % of total students) of United Kingdom?
Provide a succinct answer. -1.55. In the year 2009, what is the difference between the Female students (as % of total students) of Bosnia and Herzegovina and Female students (as % of total students) of Lesotho?
Provide a short and direct response. -0.68. In the year 2009, what is the difference between the Female students (as % of total students) of Bosnia and Herzegovina and Female students (as % of total students) of United Kingdom?
Give a very brief answer. 0.17. In the year 2009, what is the difference between the Female students (as % of total students) in Lesotho and Female students (as % of total students) in United Kingdom?
Provide a succinct answer. 0.85. In the year 2010, what is the difference between the Female students (as % of total students) of Middle East & North Africa (all income levels) and Female students (as % of total students) of Bosnia and Herzegovina?
Offer a terse response. -1.59. In the year 2010, what is the difference between the Female students (as % of total students) of Middle East & North Africa (all income levels) and Female students (as % of total students) of Lesotho?
Offer a very short reply. -1.81. In the year 2010, what is the difference between the Female students (as % of total students) in Middle East & North Africa (all income levels) and Female students (as % of total students) in United Kingdom?
Your answer should be compact. -1.4. In the year 2010, what is the difference between the Female students (as % of total students) in Bosnia and Herzegovina and Female students (as % of total students) in Lesotho?
Keep it short and to the point. -0.22. In the year 2010, what is the difference between the Female students (as % of total students) in Bosnia and Herzegovina and Female students (as % of total students) in United Kingdom?
Ensure brevity in your answer.  0.19. In the year 2010, what is the difference between the Female students (as % of total students) in Lesotho and Female students (as % of total students) in United Kingdom?
Give a very brief answer. 0.41. In the year 2011, what is the difference between the Female students (as % of total students) in Middle East & North Africa (all income levels) and Female students (as % of total students) in Bosnia and Herzegovina?
Offer a very short reply. -1.46. In the year 2011, what is the difference between the Female students (as % of total students) of Middle East & North Africa (all income levels) and Female students (as % of total students) of Lesotho?
Make the answer very short. -1.68. In the year 2011, what is the difference between the Female students (as % of total students) in Middle East & North Africa (all income levels) and Female students (as % of total students) in United Kingdom?
Your response must be concise. -1.59. In the year 2011, what is the difference between the Female students (as % of total students) in Bosnia and Herzegovina and Female students (as % of total students) in Lesotho?
Give a very brief answer. -0.22. In the year 2011, what is the difference between the Female students (as % of total students) in Bosnia and Herzegovina and Female students (as % of total students) in United Kingdom?
Provide a short and direct response. -0.13. In the year 2011, what is the difference between the Female students (as % of total students) of Lesotho and Female students (as % of total students) of United Kingdom?
Offer a terse response. 0.09. In the year 2012, what is the difference between the Female students (as % of total students) of Middle East & North Africa (all income levels) and Female students (as % of total students) of Bosnia and Herzegovina?
Provide a short and direct response. -1.26. In the year 2012, what is the difference between the Female students (as % of total students) of Middle East & North Africa (all income levels) and Female students (as % of total students) of Lesotho?
Offer a very short reply. -1.58. In the year 2012, what is the difference between the Female students (as % of total students) in Middle East & North Africa (all income levels) and Female students (as % of total students) in United Kingdom?
Provide a succinct answer. -1.44. In the year 2012, what is the difference between the Female students (as % of total students) in Bosnia and Herzegovina and Female students (as % of total students) in Lesotho?
Ensure brevity in your answer.  -0.32. In the year 2012, what is the difference between the Female students (as % of total students) in Bosnia and Herzegovina and Female students (as % of total students) in United Kingdom?
Keep it short and to the point. -0.18. In the year 2012, what is the difference between the Female students (as % of total students) of Lesotho and Female students (as % of total students) of United Kingdom?
Make the answer very short. 0.14. In the year 2013, what is the difference between the Female students (as % of total students) of Middle East & North Africa (all income levels) and Female students (as % of total students) of Bosnia and Herzegovina?
Keep it short and to the point. -0.98. In the year 2013, what is the difference between the Female students (as % of total students) in Middle East & North Africa (all income levels) and Female students (as % of total students) in Lesotho?
Your answer should be very brief. -1.47. In the year 2013, what is the difference between the Female students (as % of total students) in Middle East & North Africa (all income levels) and Female students (as % of total students) in United Kingdom?
Offer a terse response. -1.14. In the year 2013, what is the difference between the Female students (as % of total students) of Bosnia and Herzegovina and Female students (as % of total students) of Lesotho?
Provide a short and direct response. -0.49. In the year 2013, what is the difference between the Female students (as % of total students) of Bosnia and Herzegovina and Female students (as % of total students) of United Kingdom?
Give a very brief answer. -0.16. In the year 2013, what is the difference between the Female students (as % of total students) of Lesotho and Female students (as % of total students) of United Kingdom?
Your answer should be compact. 0.33. What is the ratio of the Female students (as % of total students) of Middle East & North Africa (all income levels) in 2007 to that in 2008?
Your response must be concise. 1. What is the ratio of the Female students (as % of total students) in Bosnia and Herzegovina in 2007 to that in 2008?
Offer a terse response. 1. What is the ratio of the Female students (as % of total students) of Middle East & North Africa (all income levels) in 2007 to that in 2009?
Offer a very short reply. 1. What is the ratio of the Female students (as % of total students) in Bosnia and Herzegovina in 2007 to that in 2009?
Offer a very short reply. 1. What is the ratio of the Female students (as % of total students) in United Kingdom in 2007 to that in 2009?
Keep it short and to the point. 1. What is the ratio of the Female students (as % of total students) in Bosnia and Herzegovina in 2007 to that in 2010?
Offer a terse response. 1. What is the ratio of the Female students (as % of total students) of Lesotho in 2007 to that in 2010?
Make the answer very short. 1.01. What is the ratio of the Female students (as % of total students) in Middle East & North Africa (all income levels) in 2007 to that in 2011?
Your answer should be compact. 1. What is the ratio of the Female students (as % of total students) of Bosnia and Herzegovina in 2007 to that in 2011?
Keep it short and to the point. 1. What is the ratio of the Female students (as % of total students) in United Kingdom in 2007 to that in 2011?
Ensure brevity in your answer.  1. What is the ratio of the Female students (as % of total students) of Middle East & North Africa (all income levels) in 2007 to that in 2012?
Provide a succinct answer. 0.99. What is the ratio of the Female students (as % of total students) of Bosnia and Herzegovina in 2007 to that in 2012?
Ensure brevity in your answer.  1. What is the ratio of the Female students (as % of total students) of Lesotho in 2007 to that in 2012?
Keep it short and to the point. 1.01. What is the ratio of the Female students (as % of total students) in United Kingdom in 2007 to that in 2012?
Your answer should be very brief. 1. What is the ratio of the Female students (as % of total students) of Middle East & North Africa (all income levels) in 2007 to that in 2013?
Give a very brief answer. 0.99. What is the ratio of the Female students (as % of total students) in Middle East & North Africa (all income levels) in 2008 to that in 2009?
Offer a terse response. 1. What is the ratio of the Female students (as % of total students) of Lesotho in 2008 to that in 2009?
Your answer should be very brief. 1. What is the ratio of the Female students (as % of total students) of Middle East & North Africa (all income levels) in 2008 to that in 2010?
Provide a succinct answer. 1. What is the ratio of the Female students (as % of total students) in Lesotho in 2008 to that in 2010?
Keep it short and to the point. 1.01. What is the ratio of the Female students (as % of total students) of Middle East & North Africa (all income levels) in 2008 to that in 2011?
Your response must be concise. 1. What is the ratio of the Female students (as % of total students) in Lesotho in 2008 to that in 2011?
Ensure brevity in your answer.  1.01. What is the ratio of the Female students (as % of total students) of United Kingdom in 2008 to that in 2011?
Provide a succinct answer. 1. What is the ratio of the Female students (as % of total students) of Middle East & North Africa (all income levels) in 2008 to that in 2012?
Offer a terse response. 1. What is the ratio of the Female students (as % of total students) of Lesotho in 2008 to that in 2012?
Your answer should be very brief. 1.01. What is the ratio of the Female students (as % of total students) in United Kingdom in 2008 to that in 2012?
Ensure brevity in your answer.  1. What is the ratio of the Female students (as % of total students) in Lesotho in 2008 to that in 2013?
Provide a short and direct response. 1.01. What is the ratio of the Female students (as % of total students) of Middle East & North Africa (all income levels) in 2009 to that in 2010?
Your answer should be very brief. 1. What is the ratio of the Female students (as % of total students) in Lesotho in 2009 to that in 2010?
Your answer should be very brief. 1.01. What is the ratio of the Female students (as % of total students) in United Kingdom in 2009 to that in 2011?
Your answer should be very brief. 1. What is the ratio of the Female students (as % of total students) in Middle East & North Africa (all income levels) in 2009 to that in 2012?
Offer a very short reply. 1. What is the ratio of the Female students (as % of total students) of Lesotho in 2009 to that in 2012?
Give a very brief answer. 1.01. What is the ratio of the Female students (as % of total students) of United Kingdom in 2009 to that in 2012?
Offer a terse response. 1. What is the ratio of the Female students (as % of total students) in Middle East & North Africa (all income levels) in 2009 to that in 2013?
Give a very brief answer. 0.99. What is the ratio of the Female students (as % of total students) in Lesotho in 2009 to that in 2013?
Offer a very short reply. 1.01. What is the ratio of the Female students (as % of total students) of Middle East & North Africa (all income levels) in 2010 to that in 2011?
Keep it short and to the point. 1. What is the ratio of the Female students (as % of total students) of Bosnia and Herzegovina in 2010 to that in 2012?
Provide a succinct answer. 1. What is the ratio of the Female students (as % of total students) of Lesotho in 2010 to that in 2012?
Give a very brief answer. 1. What is the ratio of the Female students (as % of total students) of United Kingdom in 2010 to that in 2012?
Your answer should be compact. 1. What is the ratio of the Female students (as % of total students) of Lesotho in 2010 to that in 2013?
Your response must be concise. 1. What is the ratio of the Female students (as % of total students) in Middle East & North Africa (all income levels) in 2011 to that in 2012?
Provide a succinct answer. 1. What is the ratio of the Female students (as % of total students) of Bosnia and Herzegovina in 2011 to that in 2012?
Give a very brief answer. 1. What is the ratio of the Female students (as % of total students) in Lesotho in 2011 to that in 2012?
Ensure brevity in your answer.  1. What is the ratio of the Female students (as % of total students) of United Kingdom in 2011 to that in 2012?
Provide a succinct answer. 1. What is the ratio of the Female students (as % of total students) in Middle East & North Africa (all income levels) in 2011 to that in 2013?
Make the answer very short. 0.99. What is the ratio of the Female students (as % of total students) of Lesotho in 2011 to that in 2013?
Make the answer very short. 0.99. What is the ratio of the Female students (as % of total students) of United Kingdom in 2011 to that in 2013?
Your answer should be compact. 1. What is the ratio of the Female students (as % of total students) of Middle East & North Africa (all income levels) in 2012 to that in 2013?
Give a very brief answer. 0.99. What is the ratio of the Female students (as % of total students) of Bosnia and Herzegovina in 2012 to that in 2013?
Offer a terse response. 1. What is the difference between the highest and the second highest Female students (as % of total students) in Middle East & North Africa (all income levels)?
Your response must be concise. 0.27. What is the difference between the highest and the second highest Female students (as % of total students) in Bosnia and Herzegovina?
Make the answer very short. 0.05. What is the difference between the highest and the second highest Female students (as % of total students) of Lesotho?
Offer a very short reply. 0.15. What is the difference between the highest and the second highest Female students (as % of total students) of United Kingdom?
Ensure brevity in your answer.  0.1. What is the difference between the highest and the lowest Female students (as % of total students) in Middle East & North Africa (all income levels)?
Your answer should be very brief. 0.59. What is the difference between the highest and the lowest Female students (as % of total students) of Bosnia and Herzegovina?
Give a very brief answer. 0.3. What is the difference between the highest and the lowest Female students (as % of total students) of Lesotho?
Your answer should be very brief. 0.73. What is the difference between the highest and the lowest Female students (as % of total students) of United Kingdom?
Keep it short and to the point. 0.25. 